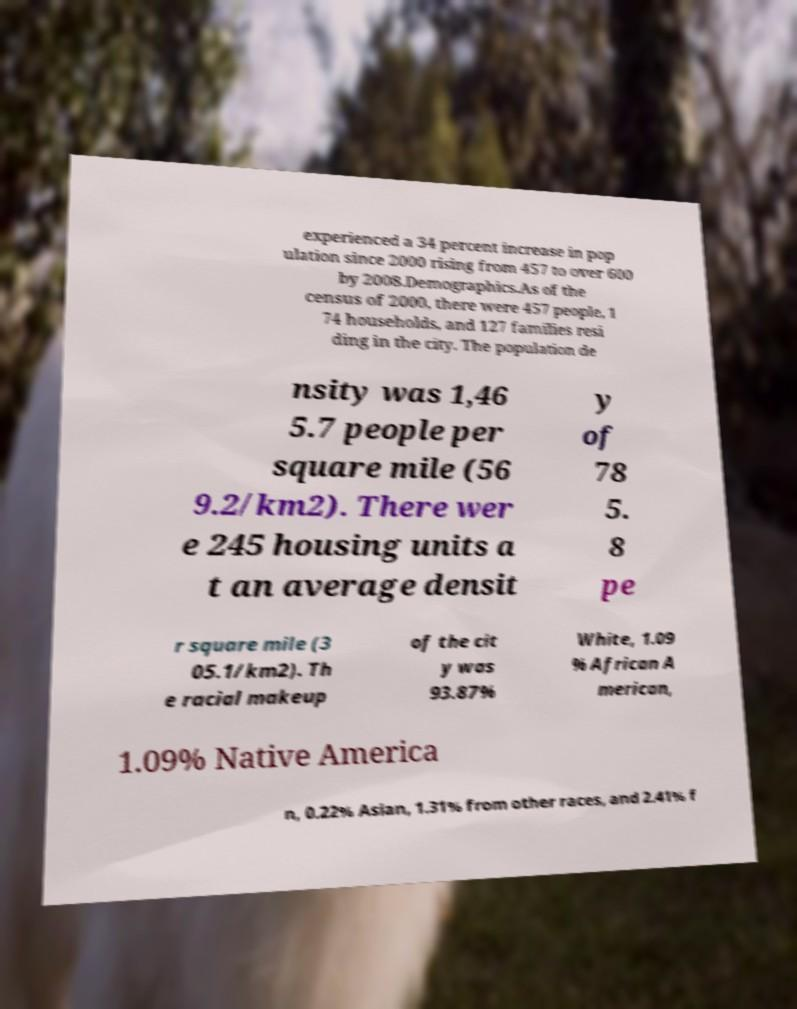For documentation purposes, I need the text within this image transcribed. Could you provide that? experienced a 34 percent increase in pop ulation since 2000 rising from 457 to over 600 by 2008.Demographics.As of the census of 2000, there were 457 people, 1 74 households, and 127 families resi ding in the city. The population de nsity was 1,46 5.7 people per square mile (56 9.2/km2). There wer e 245 housing units a t an average densit y of 78 5. 8 pe r square mile (3 05.1/km2). Th e racial makeup of the cit y was 93.87% White, 1.09 % African A merican, 1.09% Native America n, 0.22% Asian, 1.31% from other races, and 2.41% f 